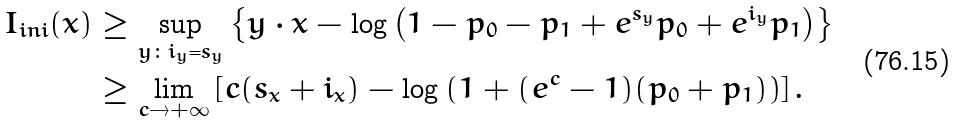Convert formula to latex. <formula><loc_0><loc_0><loc_500><loc_500>I _ { i n i } ( x ) & \geq \sup _ { y \colon i _ { y } = s _ { y } } \left \{ y \cdot x - \log \left ( 1 - p _ { 0 } - p _ { 1 } + e ^ { s _ { y } } p _ { 0 } + e ^ { i _ { y } } p _ { 1 } \right ) \right \} \\ & \geq \lim _ { c \rightarrow + \infty } \left [ c ( s _ { x } + i _ { x } ) - \log \left ( 1 + ( e ^ { c } - 1 ) ( p _ { 0 } + p _ { 1 } ) \right ) \right ] .</formula> 